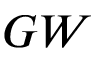<formula> <loc_0><loc_0><loc_500><loc_500>G W</formula> 